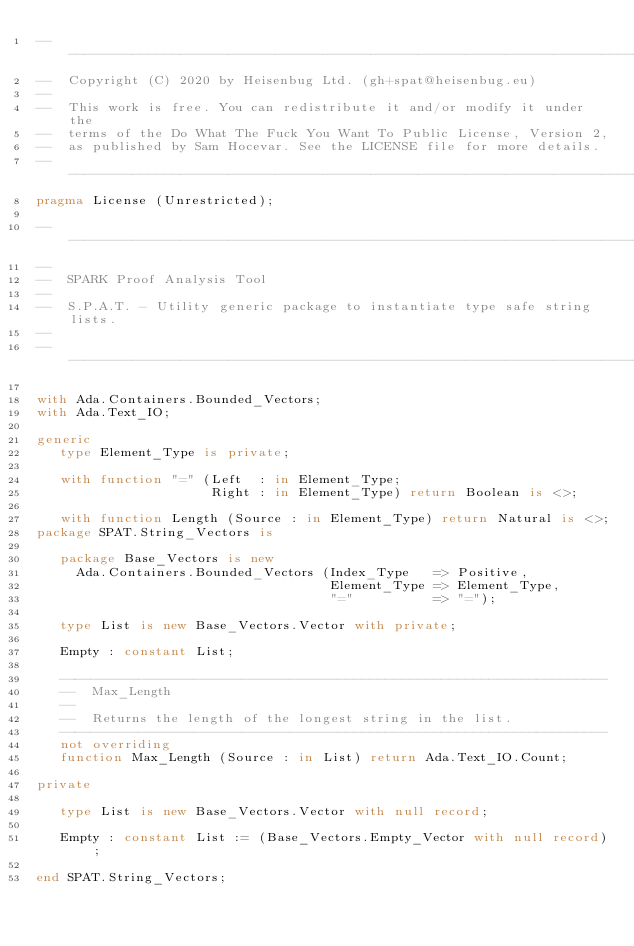Convert code to text. <code><loc_0><loc_0><loc_500><loc_500><_Ada_>------------------------------------------------------------------------------
--  Copyright (C) 2020 by Heisenbug Ltd. (gh+spat@heisenbug.eu)
--
--  This work is free. You can redistribute it and/or modify it under the
--  terms of the Do What The Fuck You Want To Public License, Version 2,
--  as published by Sam Hocevar. See the LICENSE file for more details.
------------------------------------------------------------------------------
pragma License (Unrestricted);

------------------------------------------------------------------------------
--
--  SPARK Proof Analysis Tool
--
--  S.P.A.T. - Utility generic package to instantiate type safe string lists.
--
------------------------------------------------------------------------------

with Ada.Containers.Bounded_Vectors;
with Ada.Text_IO;

generic
   type Element_Type is private;

   with function "=" (Left  : in Element_Type;
                      Right : in Element_Type) return Boolean is <>;

   with function Length (Source : in Element_Type) return Natural is <>;
package SPAT.String_Vectors is

   package Base_Vectors is new
     Ada.Containers.Bounded_Vectors (Index_Type   => Positive,
                                     Element_Type => Element_Type,
                                     "="          => "=");

   type List is new Base_Vectors.Vector with private;

   Empty : constant List;

   ---------------------------------------------------------------------
   --  Max_Length
   --
   --  Returns the length of the longest string in the list.
   ---------------------------------------------------------------------
   not overriding
   function Max_Length (Source : in List) return Ada.Text_IO.Count;

private

   type List is new Base_Vectors.Vector with null record;

   Empty : constant List := (Base_Vectors.Empty_Vector with null record);

end SPAT.String_Vectors;
</code> 